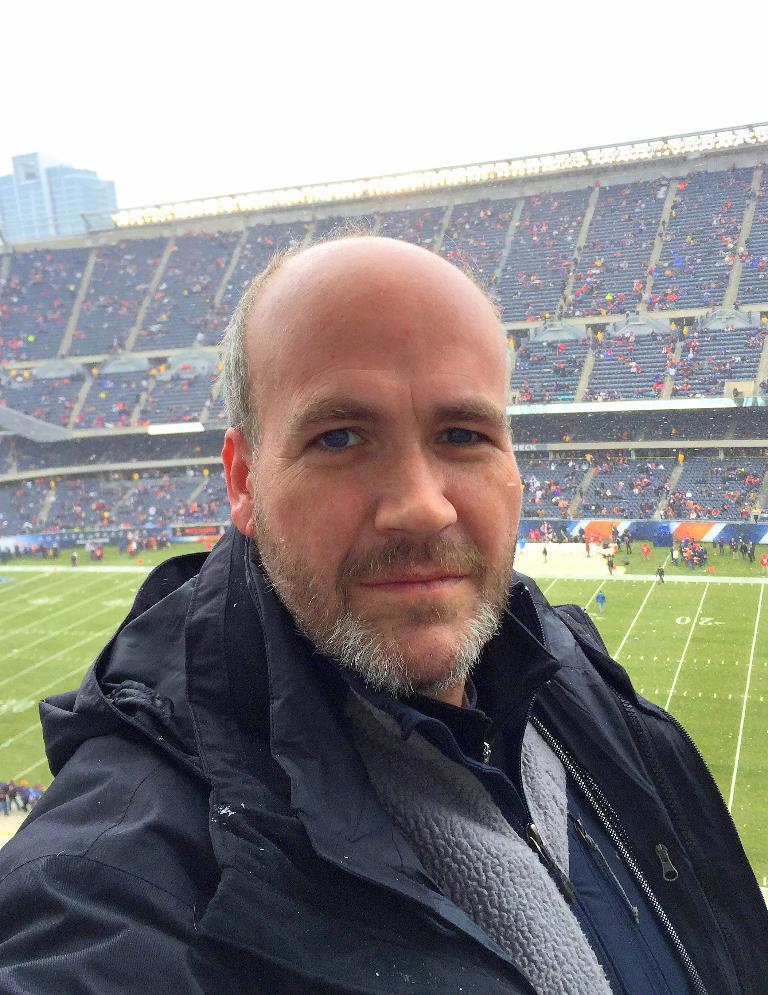How would you summarize this image in a sentence or two? In this image we can see a man. In the background we can see a stadium, ground, people, building, and sky. 